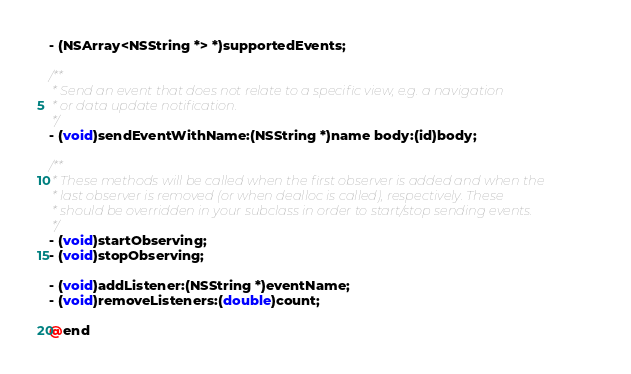Convert code to text. <code><loc_0><loc_0><loc_500><loc_500><_C_>- (NSArray<NSString *> *)supportedEvents;

/**
 * Send an event that does not relate to a specific view, e.g. a navigation
 * or data update notification.
 */
- (void)sendEventWithName:(NSString *)name body:(id)body;

/**
 * These methods will be called when the first observer is added and when the
 * last observer is removed (or when dealloc is called), respectively. These
 * should be overridden in your subclass in order to start/stop sending events.
 */
- (void)startObserving;
- (void)stopObserving;

- (void)addListener:(NSString *)eventName;
- (void)removeListeners:(double)count;

@end
</code> 